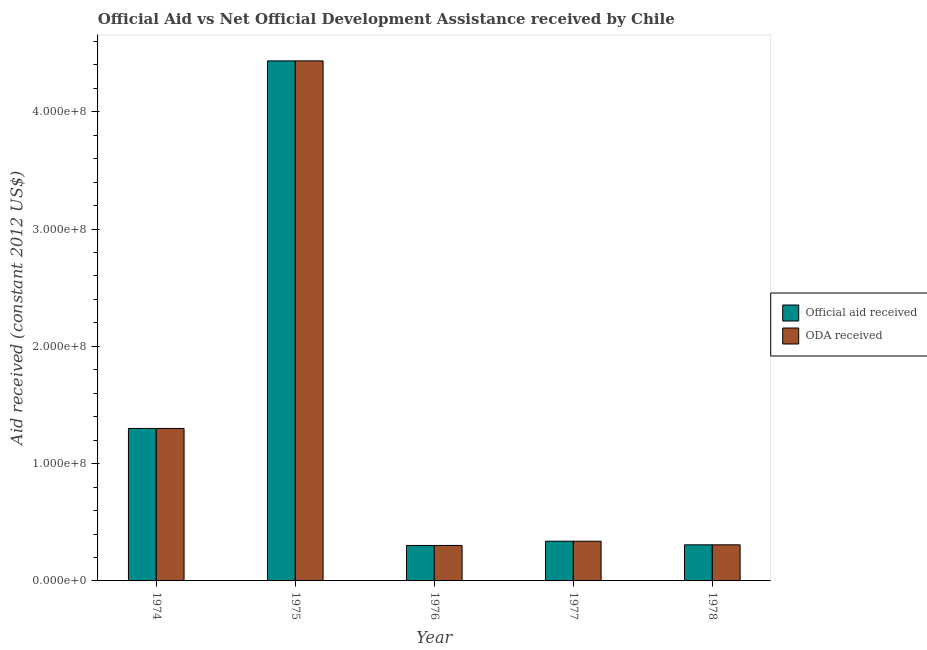How many groups of bars are there?
Your answer should be compact. 5. Are the number of bars per tick equal to the number of legend labels?
Offer a terse response. Yes. Are the number of bars on each tick of the X-axis equal?
Keep it short and to the point. Yes. How many bars are there on the 3rd tick from the left?
Provide a short and direct response. 2. How many bars are there on the 2nd tick from the right?
Offer a very short reply. 2. What is the label of the 5th group of bars from the left?
Give a very brief answer. 1978. What is the official aid received in 1978?
Provide a succinct answer. 3.08e+07. Across all years, what is the maximum official aid received?
Offer a very short reply. 4.43e+08. Across all years, what is the minimum oda received?
Give a very brief answer. 3.02e+07. In which year was the oda received maximum?
Ensure brevity in your answer.  1975. In which year was the oda received minimum?
Provide a short and direct response. 1976. What is the total oda received in the graph?
Ensure brevity in your answer.  6.68e+08. What is the difference between the official aid received in 1974 and that in 1976?
Your answer should be compact. 9.98e+07. What is the difference between the oda received in 1976 and the official aid received in 1975?
Offer a terse response. -4.13e+08. What is the average official aid received per year?
Keep it short and to the point. 1.34e+08. In how many years, is the official aid received greater than 340000000 US$?
Give a very brief answer. 1. What is the ratio of the oda received in 1974 to that in 1976?
Offer a very short reply. 4.3. What is the difference between the highest and the second highest official aid received?
Your answer should be compact. 3.13e+08. What is the difference between the highest and the lowest oda received?
Keep it short and to the point. 4.13e+08. Is the sum of the oda received in 1976 and 1977 greater than the maximum official aid received across all years?
Your response must be concise. No. What does the 2nd bar from the left in 1977 represents?
Provide a succinct answer. ODA received. What does the 1st bar from the right in 1974 represents?
Your answer should be compact. ODA received. How many years are there in the graph?
Your response must be concise. 5. What is the difference between two consecutive major ticks on the Y-axis?
Your answer should be compact. 1.00e+08. Are the values on the major ticks of Y-axis written in scientific E-notation?
Provide a short and direct response. Yes. Does the graph contain grids?
Your answer should be very brief. No. Where does the legend appear in the graph?
Offer a terse response. Center right. What is the title of the graph?
Keep it short and to the point. Official Aid vs Net Official Development Assistance received by Chile . What is the label or title of the X-axis?
Make the answer very short. Year. What is the label or title of the Y-axis?
Ensure brevity in your answer.  Aid received (constant 2012 US$). What is the Aid received (constant 2012 US$) in Official aid received in 1974?
Offer a terse response. 1.30e+08. What is the Aid received (constant 2012 US$) of ODA received in 1974?
Keep it short and to the point. 1.30e+08. What is the Aid received (constant 2012 US$) in Official aid received in 1975?
Your answer should be compact. 4.43e+08. What is the Aid received (constant 2012 US$) of ODA received in 1975?
Your answer should be very brief. 4.43e+08. What is the Aid received (constant 2012 US$) of Official aid received in 1976?
Give a very brief answer. 3.02e+07. What is the Aid received (constant 2012 US$) in ODA received in 1976?
Give a very brief answer. 3.02e+07. What is the Aid received (constant 2012 US$) in Official aid received in 1977?
Offer a terse response. 3.39e+07. What is the Aid received (constant 2012 US$) of ODA received in 1977?
Ensure brevity in your answer.  3.39e+07. What is the Aid received (constant 2012 US$) of Official aid received in 1978?
Provide a succinct answer. 3.08e+07. What is the Aid received (constant 2012 US$) of ODA received in 1978?
Ensure brevity in your answer.  3.08e+07. Across all years, what is the maximum Aid received (constant 2012 US$) in Official aid received?
Provide a short and direct response. 4.43e+08. Across all years, what is the maximum Aid received (constant 2012 US$) of ODA received?
Offer a terse response. 4.43e+08. Across all years, what is the minimum Aid received (constant 2012 US$) of Official aid received?
Keep it short and to the point. 3.02e+07. Across all years, what is the minimum Aid received (constant 2012 US$) in ODA received?
Provide a short and direct response. 3.02e+07. What is the total Aid received (constant 2012 US$) of Official aid received in the graph?
Offer a very short reply. 6.68e+08. What is the total Aid received (constant 2012 US$) in ODA received in the graph?
Your answer should be compact. 6.68e+08. What is the difference between the Aid received (constant 2012 US$) in Official aid received in 1974 and that in 1975?
Keep it short and to the point. -3.13e+08. What is the difference between the Aid received (constant 2012 US$) of ODA received in 1974 and that in 1975?
Offer a terse response. -3.13e+08. What is the difference between the Aid received (constant 2012 US$) of Official aid received in 1974 and that in 1976?
Offer a very short reply. 9.98e+07. What is the difference between the Aid received (constant 2012 US$) in ODA received in 1974 and that in 1976?
Give a very brief answer. 9.98e+07. What is the difference between the Aid received (constant 2012 US$) in Official aid received in 1974 and that in 1977?
Your answer should be very brief. 9.61e+07. What is the difference between the Aid received (constant 2012 US$) in ODA received in 1974 and that in 1977?
Provide a short and direct response. 9.61e+07. What is the difference between the Aid received (constant 2012 US$) of Official aid received in 1974 and that in 1978?
Offer a terse response. 9.92e+07. What is the difference between the Aid received (constant 2012 US$) of ODA received in 1974 and that in 1978?
Offer a terse response. 9.92e+07. What is the difference between the Aid received (constant 2012 US$) in Official aid received in 1975 and that in 1976?
Your answer should be compact. 4.13e+08. What is the difference between the Aid received (constant 2012 US$) in ODA received in 1975 and that in 1976?
Give a very brief answer. 4.13e+08. What is the difference between the Aid received (constant 2012 US$) of Official aid received in 1975 and that in 1977?
Your answer should be compact. 4.10e+08. What is the difference between the Aid received (constant 2012 US$) of ODA received in 1975 and that in 1977?
Provide a succinct answer. 4.10e+08. What is the difference between the Aid received (constant 2012 US$) in Official aid received in 1975 and that in 1978?
Provide a short and direct response. 4.13e+08. What is the difference between the Aid received (constant 2012 US$) in ODA received in 1975 and that in 1978?
Offer a very short reply. 4.13e+08. What is the difference between the Aid received (constant 2012 US$) in Official aid received in 1976 and that in 1977?
Provide a short and direct response. -3.62e+06. What is the difference between the Aid received (constant 2012 US$) of ODA received in 1976 and that in 1977?
Offer a terse response. -3.62e+06. What is the difference between the Aid received (constant 2012 US$) in Official aid received in 1976 and that in 1978?
Offer a terse response. -5.30e+05. What is the difference between the Aid received (constant 2012 US$) in ODA received in 1976 and that in 1978?
Your response must be concise. -5.30e+05. What is the difference between the Aid received (constant 2012 US$) of Official aid received in 1977 and that in 1978?
Give a very brief answer. 3.09e+06. What is the difference between the Aid received (constant 2012 US$) in ODA received in 1977 and that in 1978?
Provide a short and direct response. 3.09e+06. What is the difference between the Aid received (constant 2012 US$) of Official aid received in 1974 and the Aid received (constant 2012 US$) of ODA received in 1975?
Give a very brief answer. -3.13e+08. What is the difference between the Aid received (constant 2012 US$) of Official aid received in 1974 and the Aid received (constant 2012 US$) of ODA received in 1976?
Your answer should be very brief. 9.98e+07. What is the difference between the Aid received (constant 2012 US$) in Official aid received in 1974 and the Aid received (constant 2012 US$) in ODA received in 1977?
Keep it short and to the point. 9.61e+07. What is the difference between the Aid received (constant 2012 US$) of Official aid received in 1974 and the Aid received (constant 2012 US$) of ODA received in 1978?
Keep it short and to the point. 9.92e+07. What is the difference between the Aid received (constant 2012 US$) of Official aid received in 1975 and the Aid received (constant 2012 US$) of ODA received in 1976?
Make the answer very short. 4.13e+08. What is the difference between the Aid received (constant 2012 US$) of Official aid received in 1975 and the Aid received (constant 2012 US$) of ODA received in 1977?
Offer a very short reply. 4.10e+08. What is the difference between the Aid received (constant 2012 US$) of Official aid received in 1975 and the Aid received (constant 2012 US$) of ODA received in 1978?
Offer a terse response. 4.13e+08. What is the difference between the Aid received (constant 2012 US$) in Official aid received in 1976 and the Aid received (constant 2012 US$) in ODA received in 1977?
Give a very brief answer. -3.62e+06. What is the difference between the Aid received (constant 2012 US$) of Official aid received in 1976 and the Aid received (constant 2012 US$) of ODA received in 1978?
Your answer should be compact. -5.30e+05. What is the difference between the Aid received (constant 2012 US$) of Official aid received in 1977 and the Aid received (constant 2012 US$) of ODA received in 1978?
Your response must be concise. 3.09e+06. What is the average Aid received (constant 2012 US$) in Official aid received per year?
Offer a terse response. 1.34e+08. What is the average Aid received (constant 2012 US$) in ODA received per year?
Your response must be concise. 1.34e+08. In the year 1974, what is the difference between the Aid received (constant 2012 US$) in Official aid received and Aid received (constant 2012 US$) in ODA received?
Offer a terse response. 0. In the year 1976, what is the difference between the Aid received (constant 2012 US$) of Official aid received and Aid received (constant 2012 US$) of ODA received?
Keep it short and to the point. 0. In the year 1977, what is the difference between the Aid received (constant 2012 US$) in Official aid received and Aid received (constant 2012 US$) in ODA received?
Give a very brief answer. 0. In the year 1978, what is the difference between the Aid received (constant 2012 US$) of Official aid received and Aid received (constant 2012 US$) of ODA received?
Your answer should be very brief. 0. What is the ratio of the Aid received (constant 2012 US$) in Official aid received in 1974 to that in 1975?
Your answer should be compact. 0.29. What is the ratio of the Aid received (constant 2012 US$) in ODA received in 1974 to that in 1975?
Provide a short and direct response. 0.29. What is the ratio of the Aid received (constant 2012 US$) in Official aid received in 1974 to that in 1976?
Ensure brevity in your answer.  4.3. What is the ratio of the Aid received (constant 2012 US$) in ODA received in 1974 to that in 1976?
Offer a terse response. 4.3. What is the ratio of the Aid received (constant 2012 US$) in Official aid received in 1974 to that in 1977?
Keep it short and to the point. 3.84. What is the ratio of the Aid received (constant 2012 US$) in ODA received in 1974 to that in 1977?
Provide a short and direct response. 3.84. What is the ratio of the Aid received (constant 2012 US$) in Official aid received in 1974 to that in 1978?
Keep it short and to the point. 4.22. What is the ratio of the Aid received (constant 2012 US$) in ODA received in 1974 to that in 1978?
Make the answer very short. 4.22. What is the ratio of the Aid received (constant 2012 US$) in Official aid received in 1975 to that in 1976?
Keep it short and to the point. 14.66. What is the ratio of the Aid received (constant 2012 US$) of ODA received in 1975 to that in 1976?
Provide a succinct answer. 14.66. What is the ratio of the Aid received (constant 2012 US$) in Official aid received in 1975 to that in 1977?
Provide a succinct answer. 13.09. What is the ratio of the Aid received (constant 2012 US$) of ODA received in 1975 to that in 1977?
Ensure brevity in your answer.  13.09. What is the ratio of the Aid received (constant 2012 US$) in Official aid received in 1975 to that in 1978?
Your response must be concise. 14.41. What is the ratio of the Aid received (constant 2012 US$) of ODA received in 1975 to that in 1978?
Keep it short and to the point. 14.41. What is the ratio of the Aid received (constant 2012 US$) in Official aid received in 1976 to that in 1977?
Your response must be concise. 0.89. What is the ratio of the Aid received (constant 2012 US$) of ODA received in 1976 to that in 1977?
Give a very brief answer. 0.89. What is the ratio of the Aid received (constant 2012 US$) of Official aid received in 1976 to that in 1978?
Make the answer very short. 0.98. What is the ratio of the Aid received (constant 2012 US$) in ODA received in 1976 to that in 1978?
Your answer should be very brief. 0.98. What is the ratio of the Aid received (constant 2012 US$) in Official aid received in 1977 to that in 1978?
Offer a terse response. 1.1. What is the ratio of the Aid received (constant 2012 US$) of ODA received in 1977 to that in 1978?
Offer a very short reply. 1.1. What is the difference between the highest and the second highest Aid received (constant 2012 US$) of Official aid received?
Your answer should be very brief. 3.13e+08. What is the difference between the highest and the second highest Aid received (constant 2012 US$) in ODA received?
Offer a terse response. 3.13e+08. What is the difference between the highest and the lowest Aid received (constant 2012 US$) in Official aid received?
Provide a succinct answer. 4.13e+08. What is the difference between the highest and the lowest Aid received (constant 2012 US$) of ODA received?
Offer a terse response. 4.13e+08. 